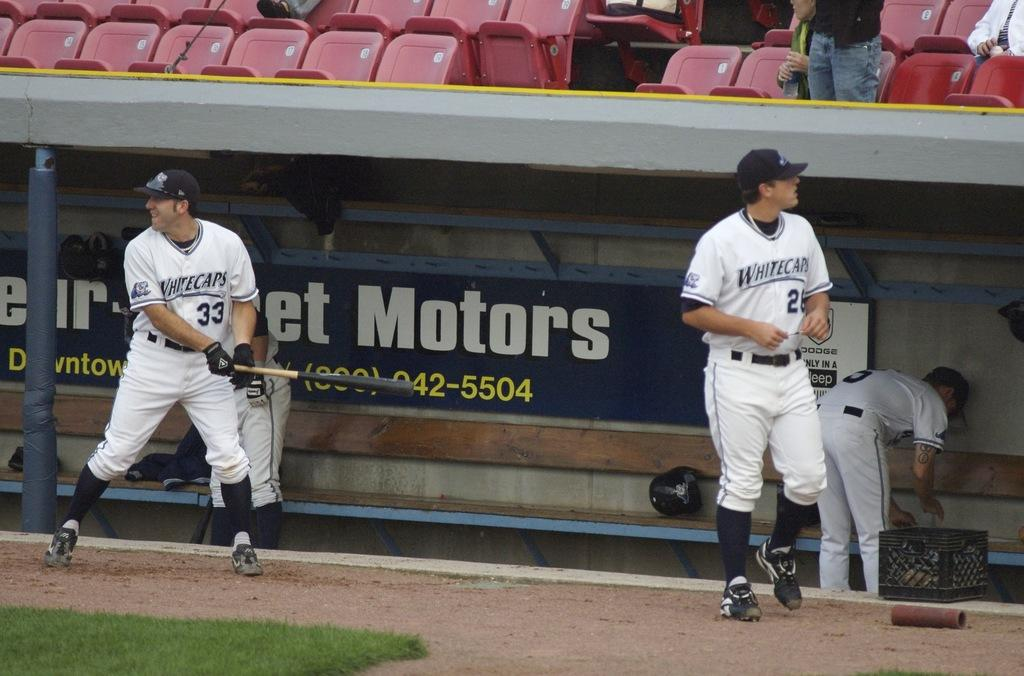<image>
Summarize the visual content of the image. A man holding a bat has the number 33 on his jersey. 